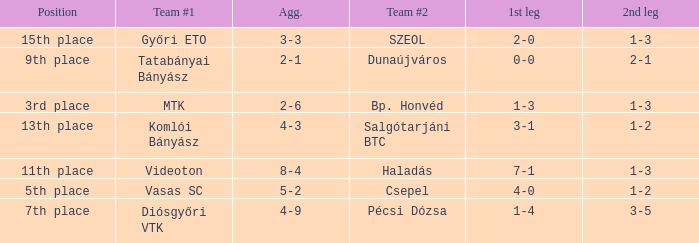What is the 1st leg with a 4-3 agg.? 3-1. 